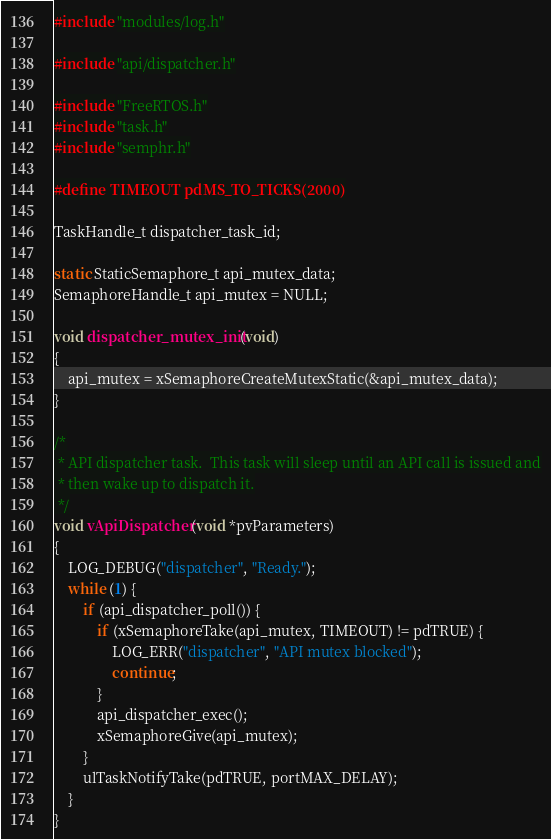<code> <loc_0><loc_0><loc_500><loc_500><_C_>#include "modules/log.h"

#include "api/dispatcher.h"

#include "FreeRTOS.h"
#include "task.h"
#include "semphr.h"

#define TIMEOUT pdMS_TO_TICKS(2000)

TaskHandle_t dispatcher_task_id;

static StaticSemaphore_t api_mutex_data;
SemaphoreHandle_t api_mutex = NULL;

void dispatcher_mutex_init(void)
{
	api_mutex = xSemaphoreCreateMutexStatic(&api_mutex_data);
}

/*
 * API dispatcher task.  This task will sleep until an API call is issued and
 * then wake up to dispatch it.
 */
void vApiDispatcher(void *pvParameters)
{
	LOG_DEBUG("dispatcher", "Ready.");
	while (1) {
		if (api_dispatcher_poll()) {
			if (xSemaphoreTake(api_mutex, TIMEOUT) != pdTRUE) {
				LOG_ERR("dispatcher", "API mutex blocked");
				continue;
			}
			api_dispatcher_exec();
			xSemaphoreGive(api_mutex);
		}
		ulTaskNotifyTake(pdTRUE, portMAX_DELAY);
	}
}
</code> 